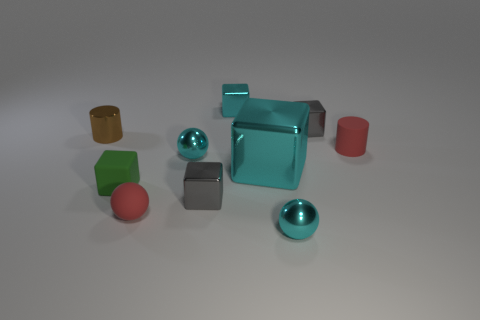Subtract all tiny green matte cubes. How many cubes are left? 4 Subtract all green blocks. How many blocks are left? 4 Subtract all blue cubes. Subtract all red balls. How many cubes are left? 5 Subtract all cylinders. How many objects are left? 8 Add 3 red matte cylinders. How many red matte cylinders are left? 4 Add 8 tiny blue matte cubes. How many tiny blue matte cubes exist? 8 Subtract 0 yellow cylinders. How many objects are left? 10 Subtract all purple shiny cylinders. Subtract all large cyan blocks. How many objects are left? 9 